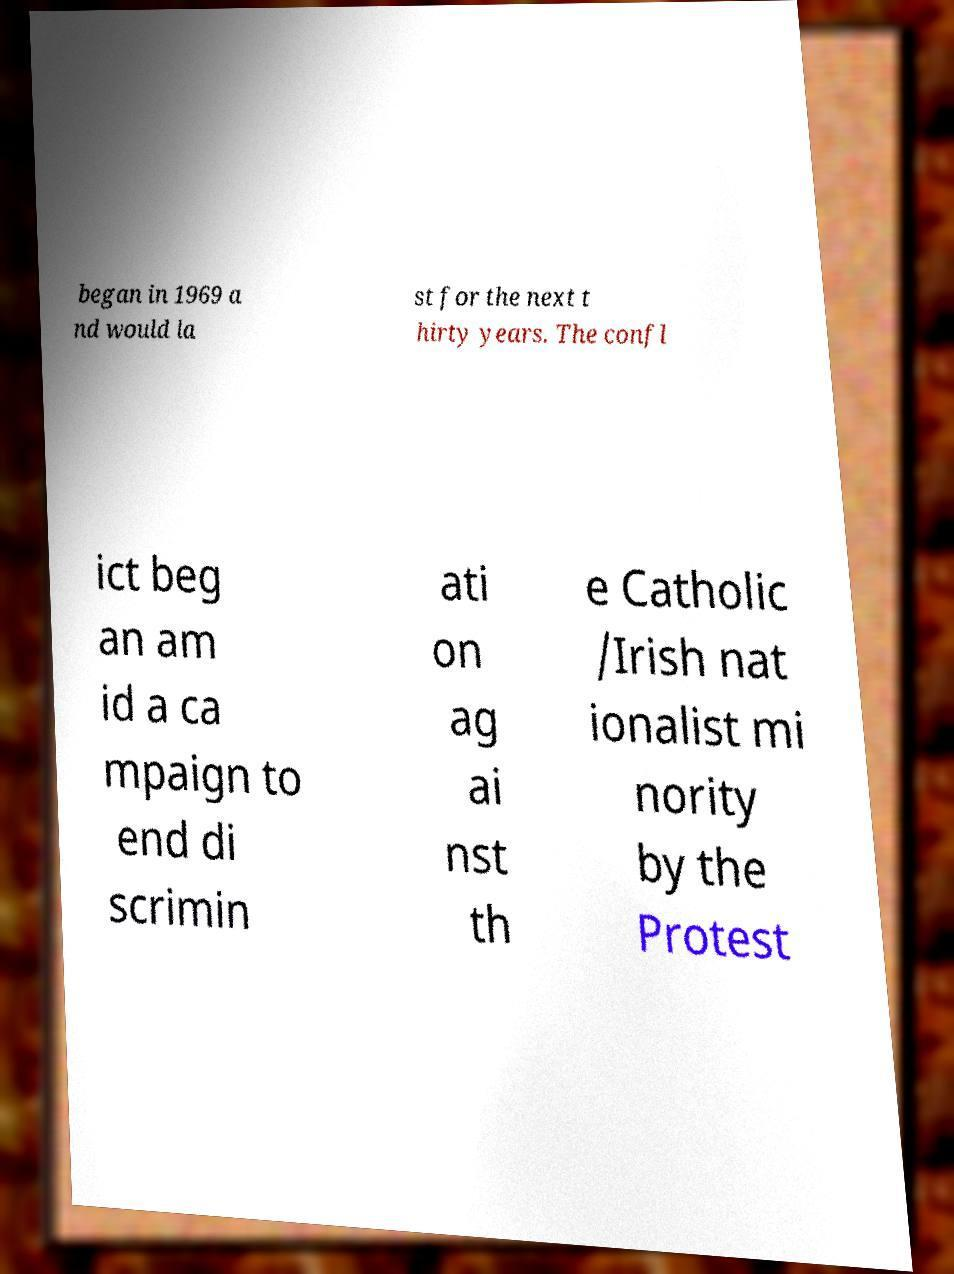Can you accurately transcribe the text from the provided image for me? began in 1969 a nd would la st for the next t hirty years. The confl ict beg an am id a ca mpaign to end di scrimin ati on ag ai nst th e Catholic /Irish nat ionalist mi nority by the Protest 